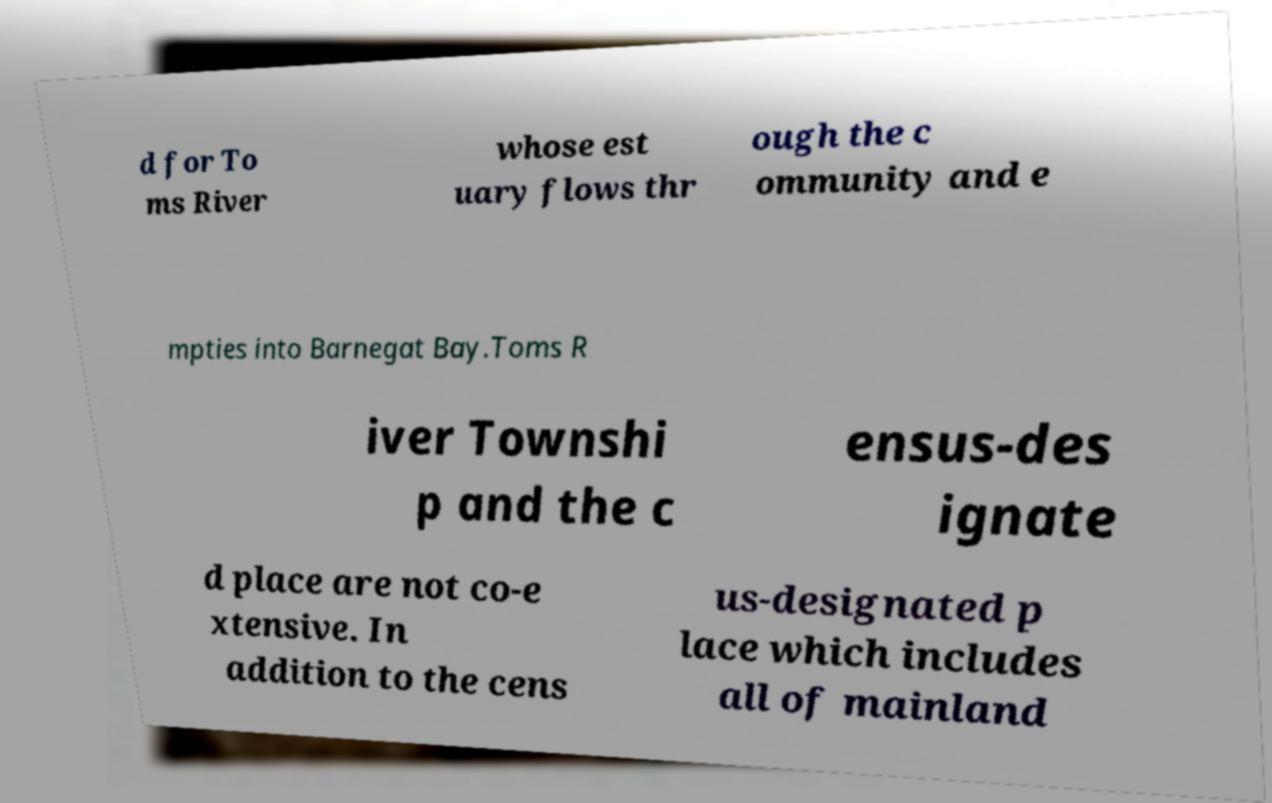I need the written content from this picture converted into text. Can you do that? d for To ms River whose est uary flows thr ough the c ommunity and e mpties into Barnegat Bay.Toms R iver Townshi p and the c ensus-des ignate d place are not co-e xtensive. In addition to the cens us-designated p lace which includes all of mainland 